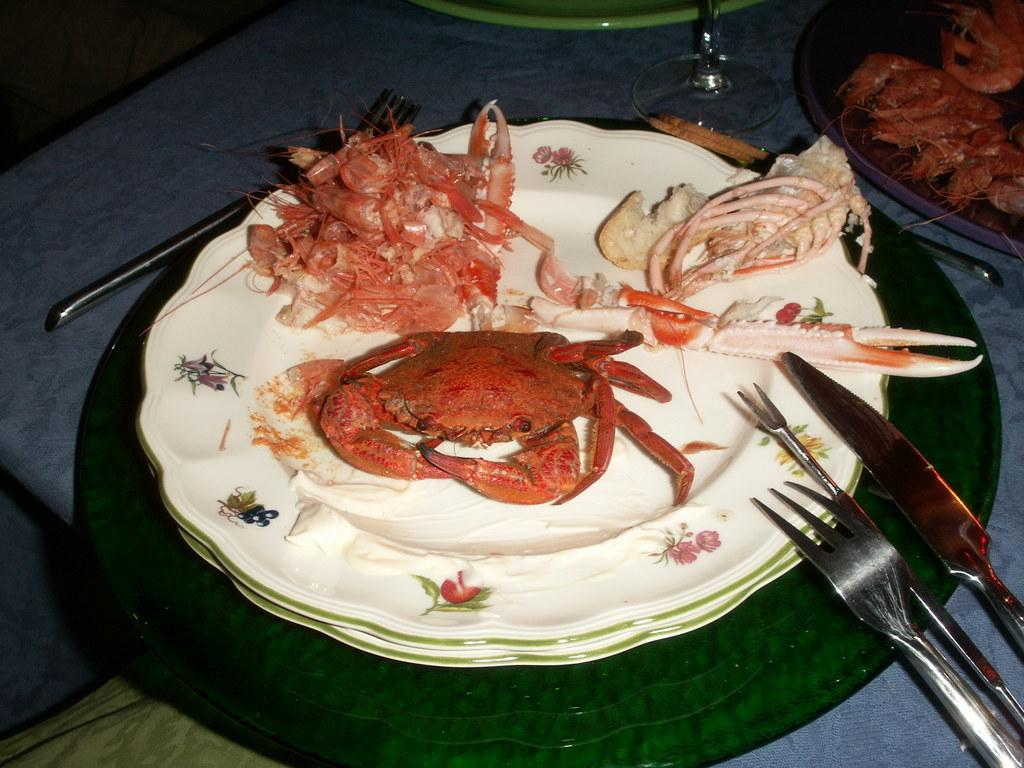What piece of furniture is present in the image? There is a table in the image. What is placed on the table? There is a plate on the table. What can be found on the plate? There are food items in the plate. What utensils are visible in the image? There is a spoon, a fork, and a knife in the image. What additional item is present in the image? There is a cloth in the image. How many cows are grazing on the cheese in the image? There are no cows or cheese present in the image. 